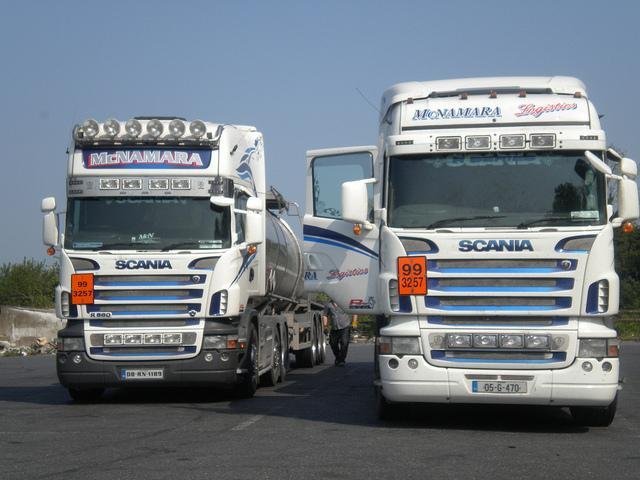What business are these vehicles in?

Choices:
A) movers
B) tourism
C) logistics
D) gas transportation logistics 